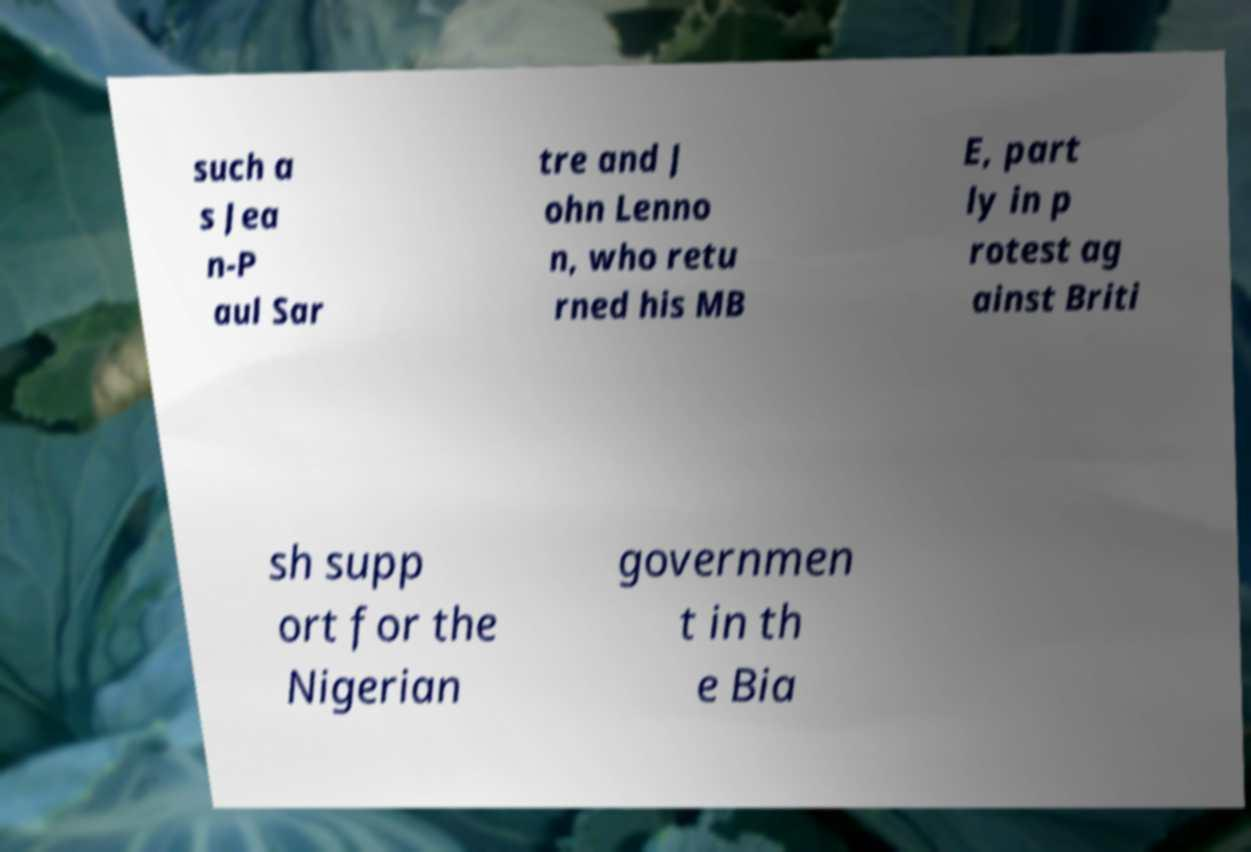What messages or text are displayed in this image? I need them in a readable, typed format. such a s Jea n-P aul Sar tre and J ohn Lenno n, who retu rned his MB E, part ly in p rotest ag ainst Briti sh supp ort for the Nigerian governmen t in th e Bia 